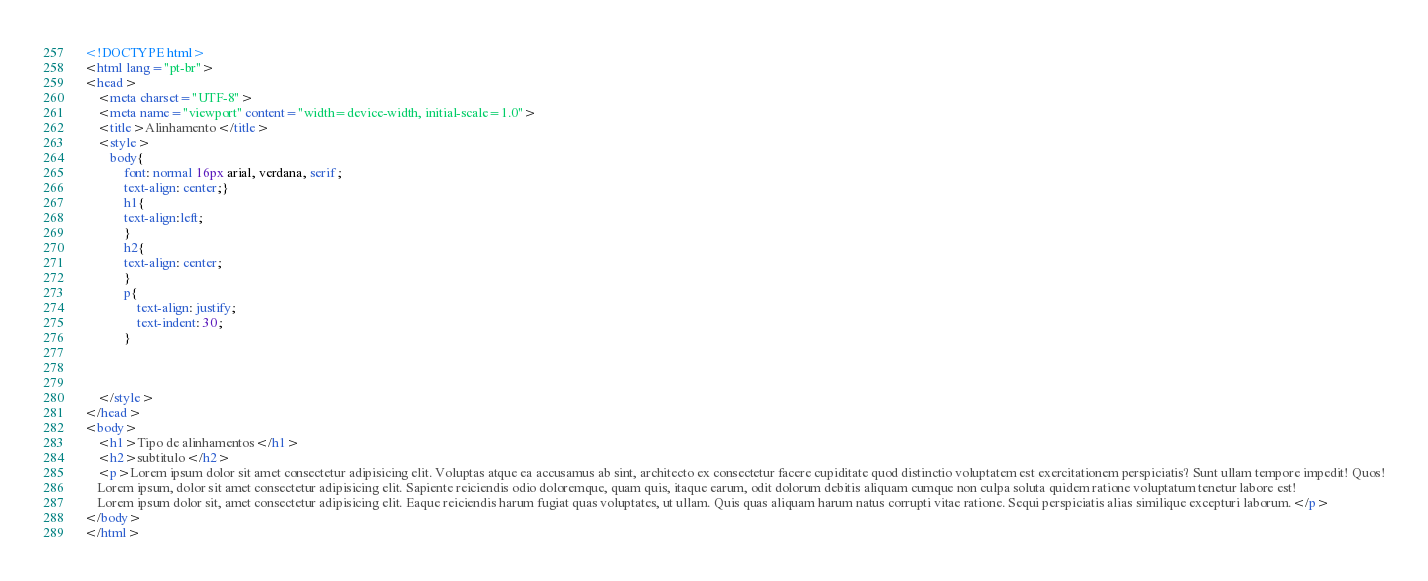<code> <loc_0><loc_0><loc_500><loc_500><_HTML_><!DOCTYPE html>
<html lang="pt-br">
<head>
    <meta charset="UTF-8">
    <meta name="viewport" content="width=device-width, initial-scale=1.0">
    <title>Alinhamento</title>
    <style>
        body{
            font: normal 16px arial, verdana, serif;
            text-align: center;}
            h1{
            text-align:left;
            }
            h2{
            text-align: center;    
            }
            p{
                text-align: justify;
                text-indent: 30;
            }
         
            
        
    </style>
</head>
<body>
    <h1>Tipo de alinhamentos</h1>
    <h2>subtitulo</h2>
    <p>Lorem ipsum dolor sit amet consectetur adipisicing elit. Voluptas atque ea accusamus ab sint, architecto ex consectetur facere cupiditate quod distinctio voluptatem est exercitationem perspiciatis? Sunt ullam tempore impedit! Quos!
    Lorem ipsum, dolor sit amet consectetur adipisicing elit. Sapiente reiciendis odio doloremque, quam quis, itaque earum, odit dolorum debitis aliquam cumque non culpa soluta quidem ratione voluptatum tenetur labore est!
    Lorem ipsum dolor sit, amet consectetur adipisicing elit. Eaque reiciendis harum fugiat quas voluptates, ut ullam. Quis quas aliquam harum natus corrupti vitae ratione. Sequi perspiciatis alias similique excepturi laborum.</p>
</body>
</html></code> 